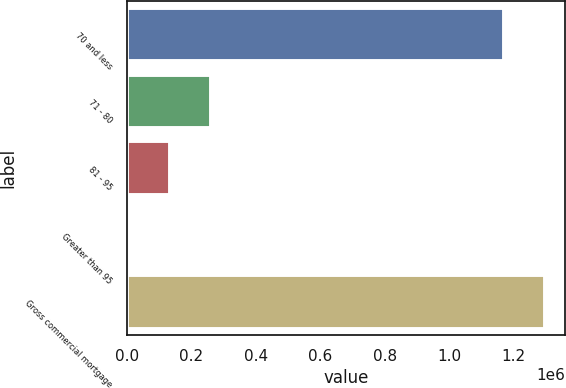Convert chart to OTSL. <chart><loc_0><loc_0><loc_500><loc_500><bar_chart><fcel>70 and less<fcel>71 - 80<fcel>81 - 95<fcel>Greater than 95<fcel>Gross commercial mortgage<nl><fcel>1.16845e+06<fcel>260428<fcel>133479<fcel>6531<fcel>1.2954e+06<nl></chart> 